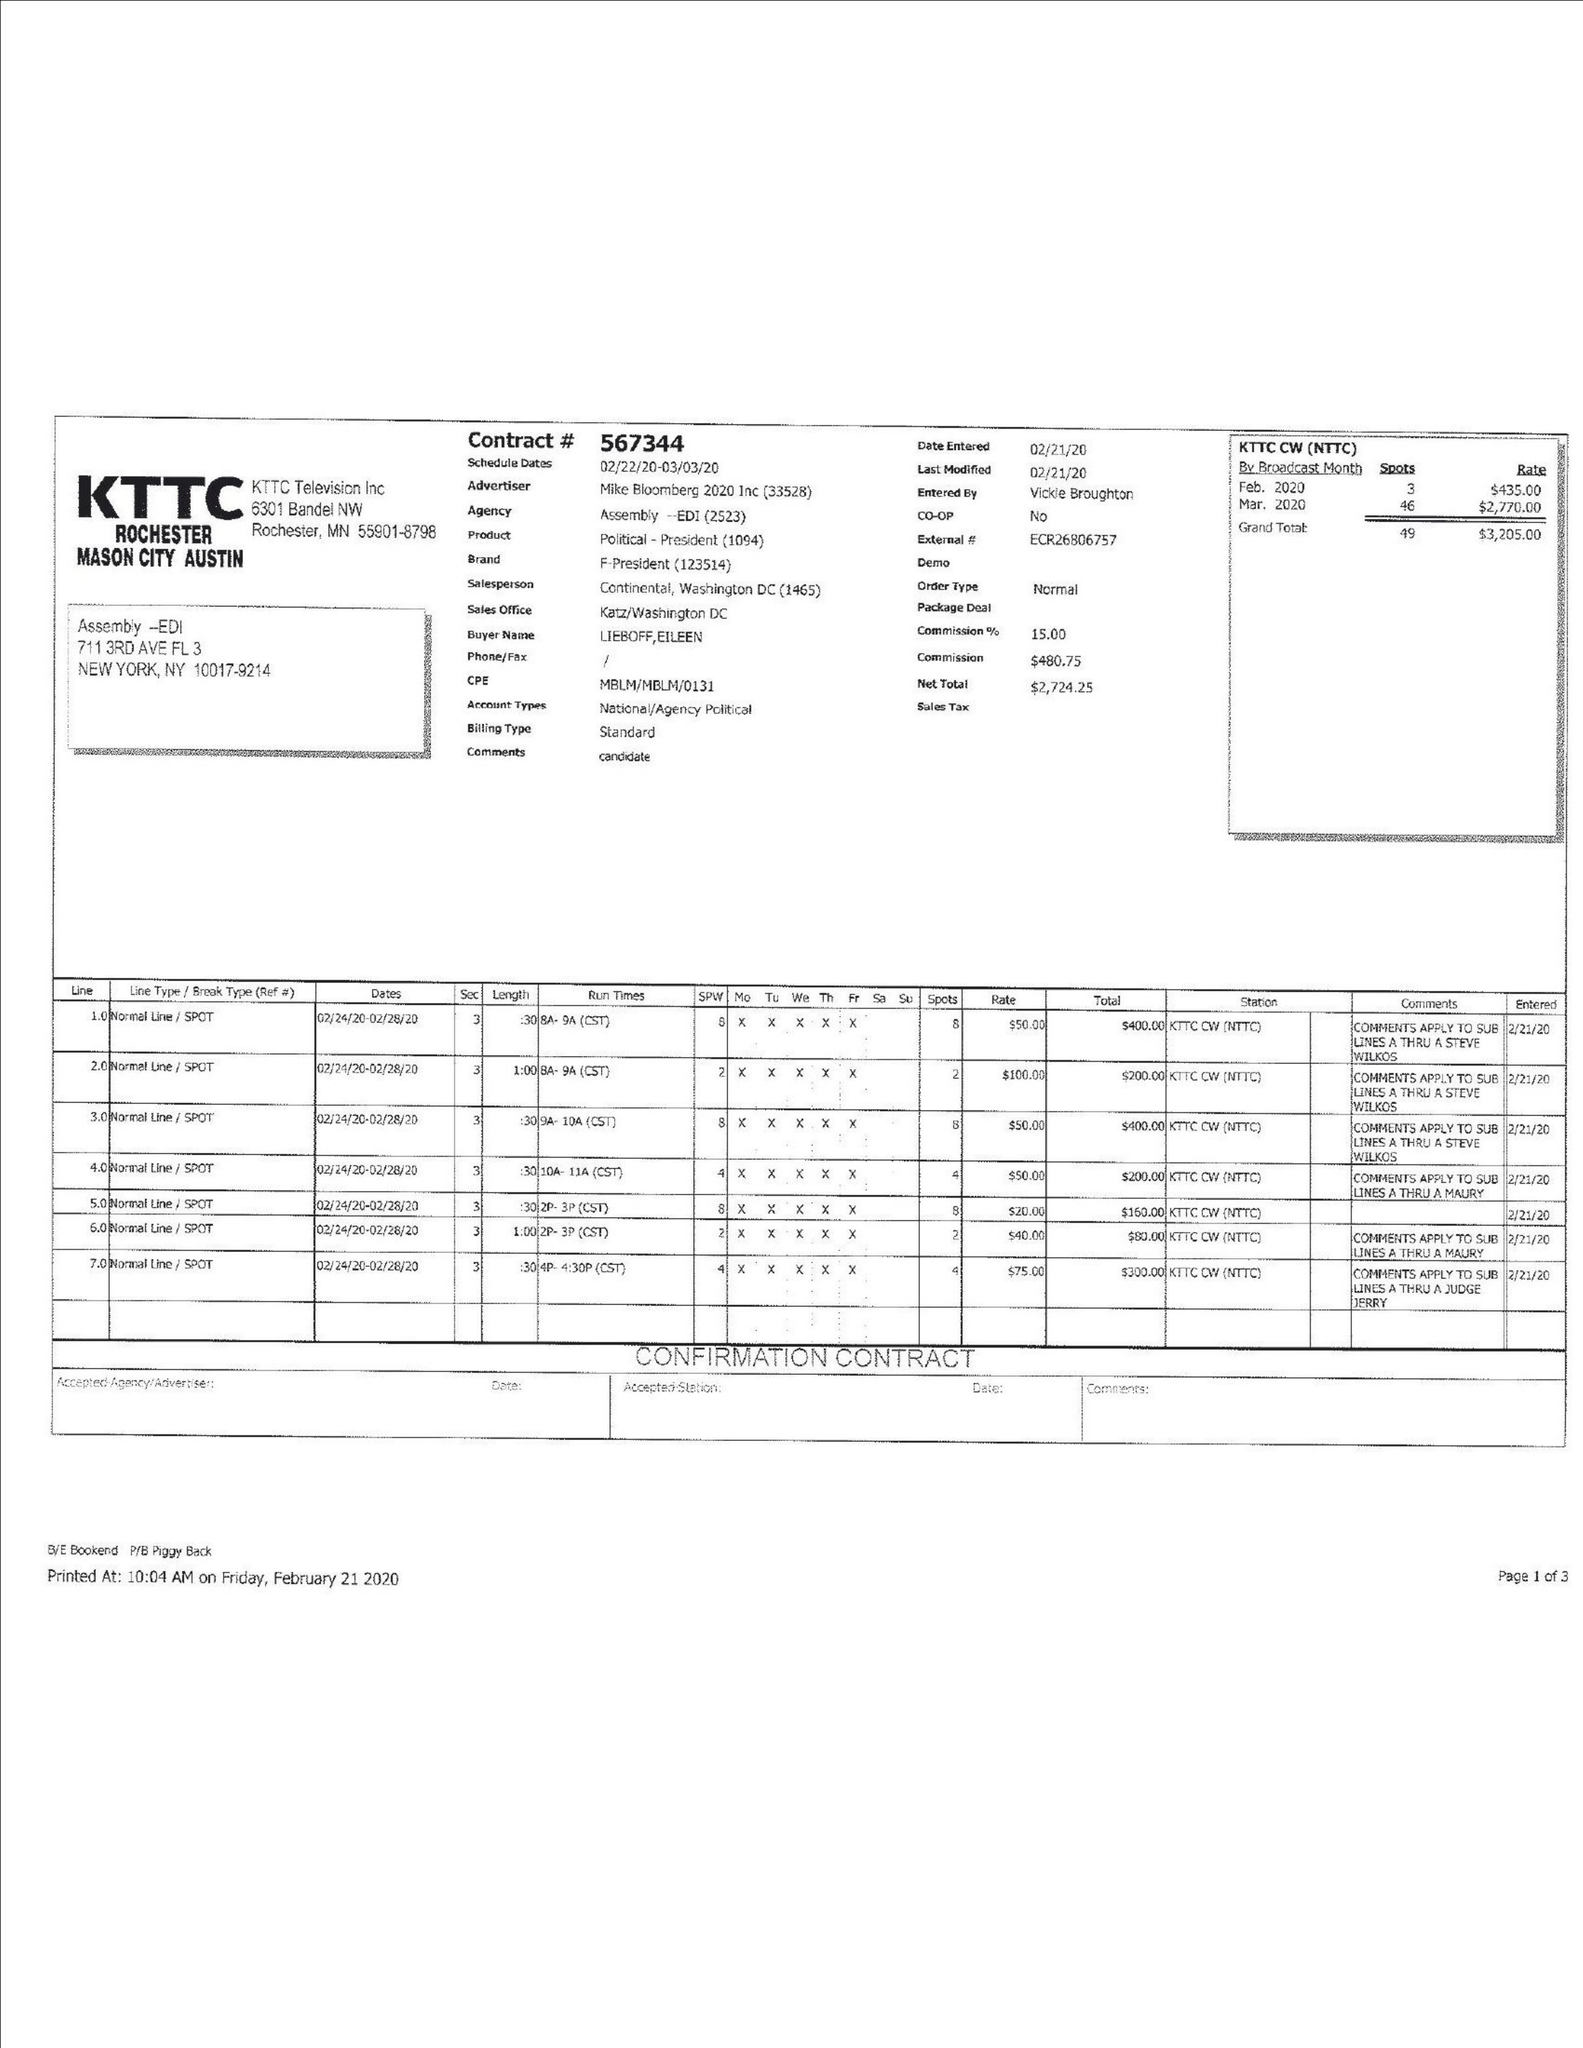What is the value for the flight_to?
Answer the question using a single word or phrase. 03/03/20 